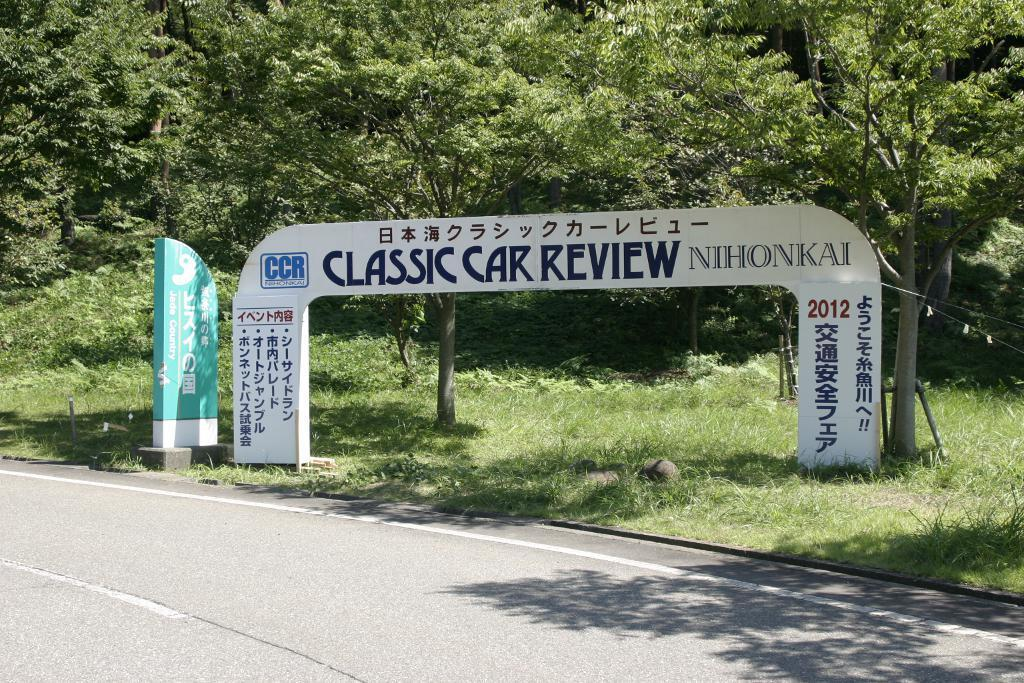What is the main feature of the image? There is a road in the image. What can be seen near the road? There are boards visible near the road. What type of natural elements are present in the image? There are trees present in the image. What type of oil can be seen dripping from the trees in the image? There is no oil present in the image, and the trees are not depicted as dripping anything. 